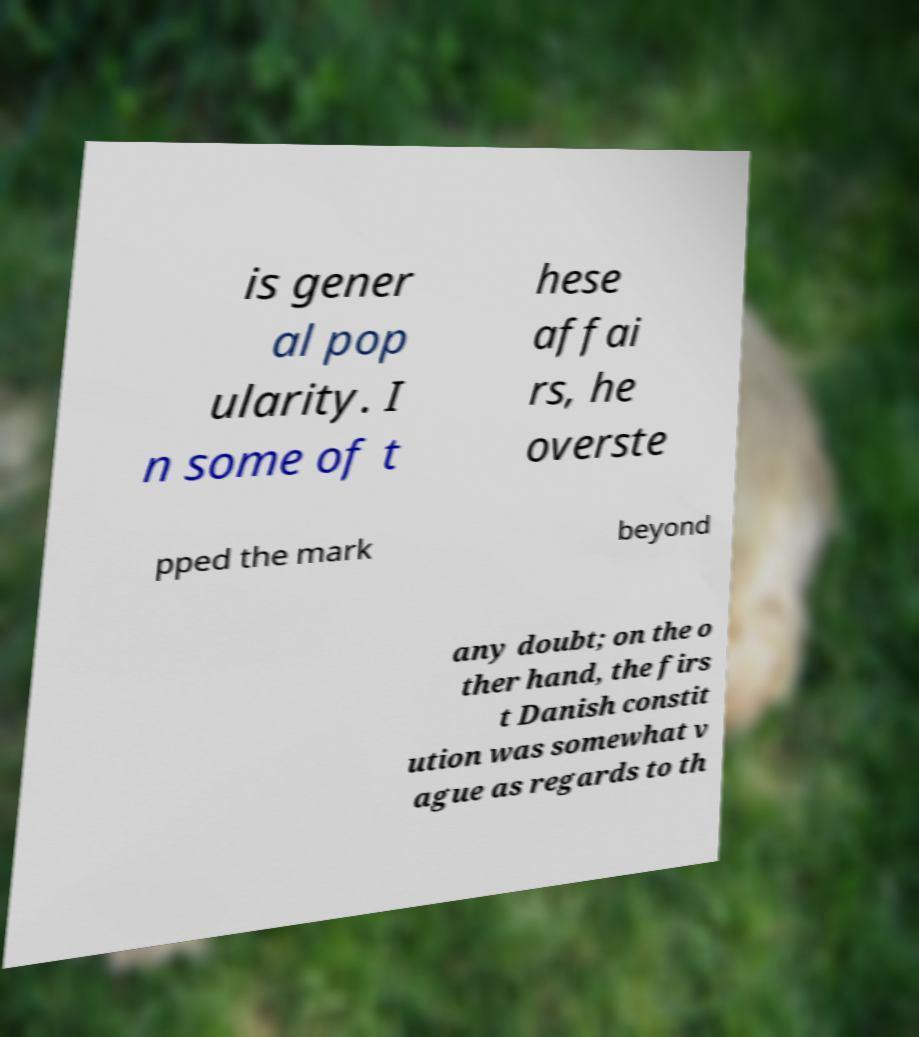Can you accurately transcribe the text from the provided image for me? is gener al pop ularity. I n some of t hese affai rs, he overste pped the mark beyond any doubt; on the o ther hand, the firs t Danish constit ution was somewhat v ague as regards to th 